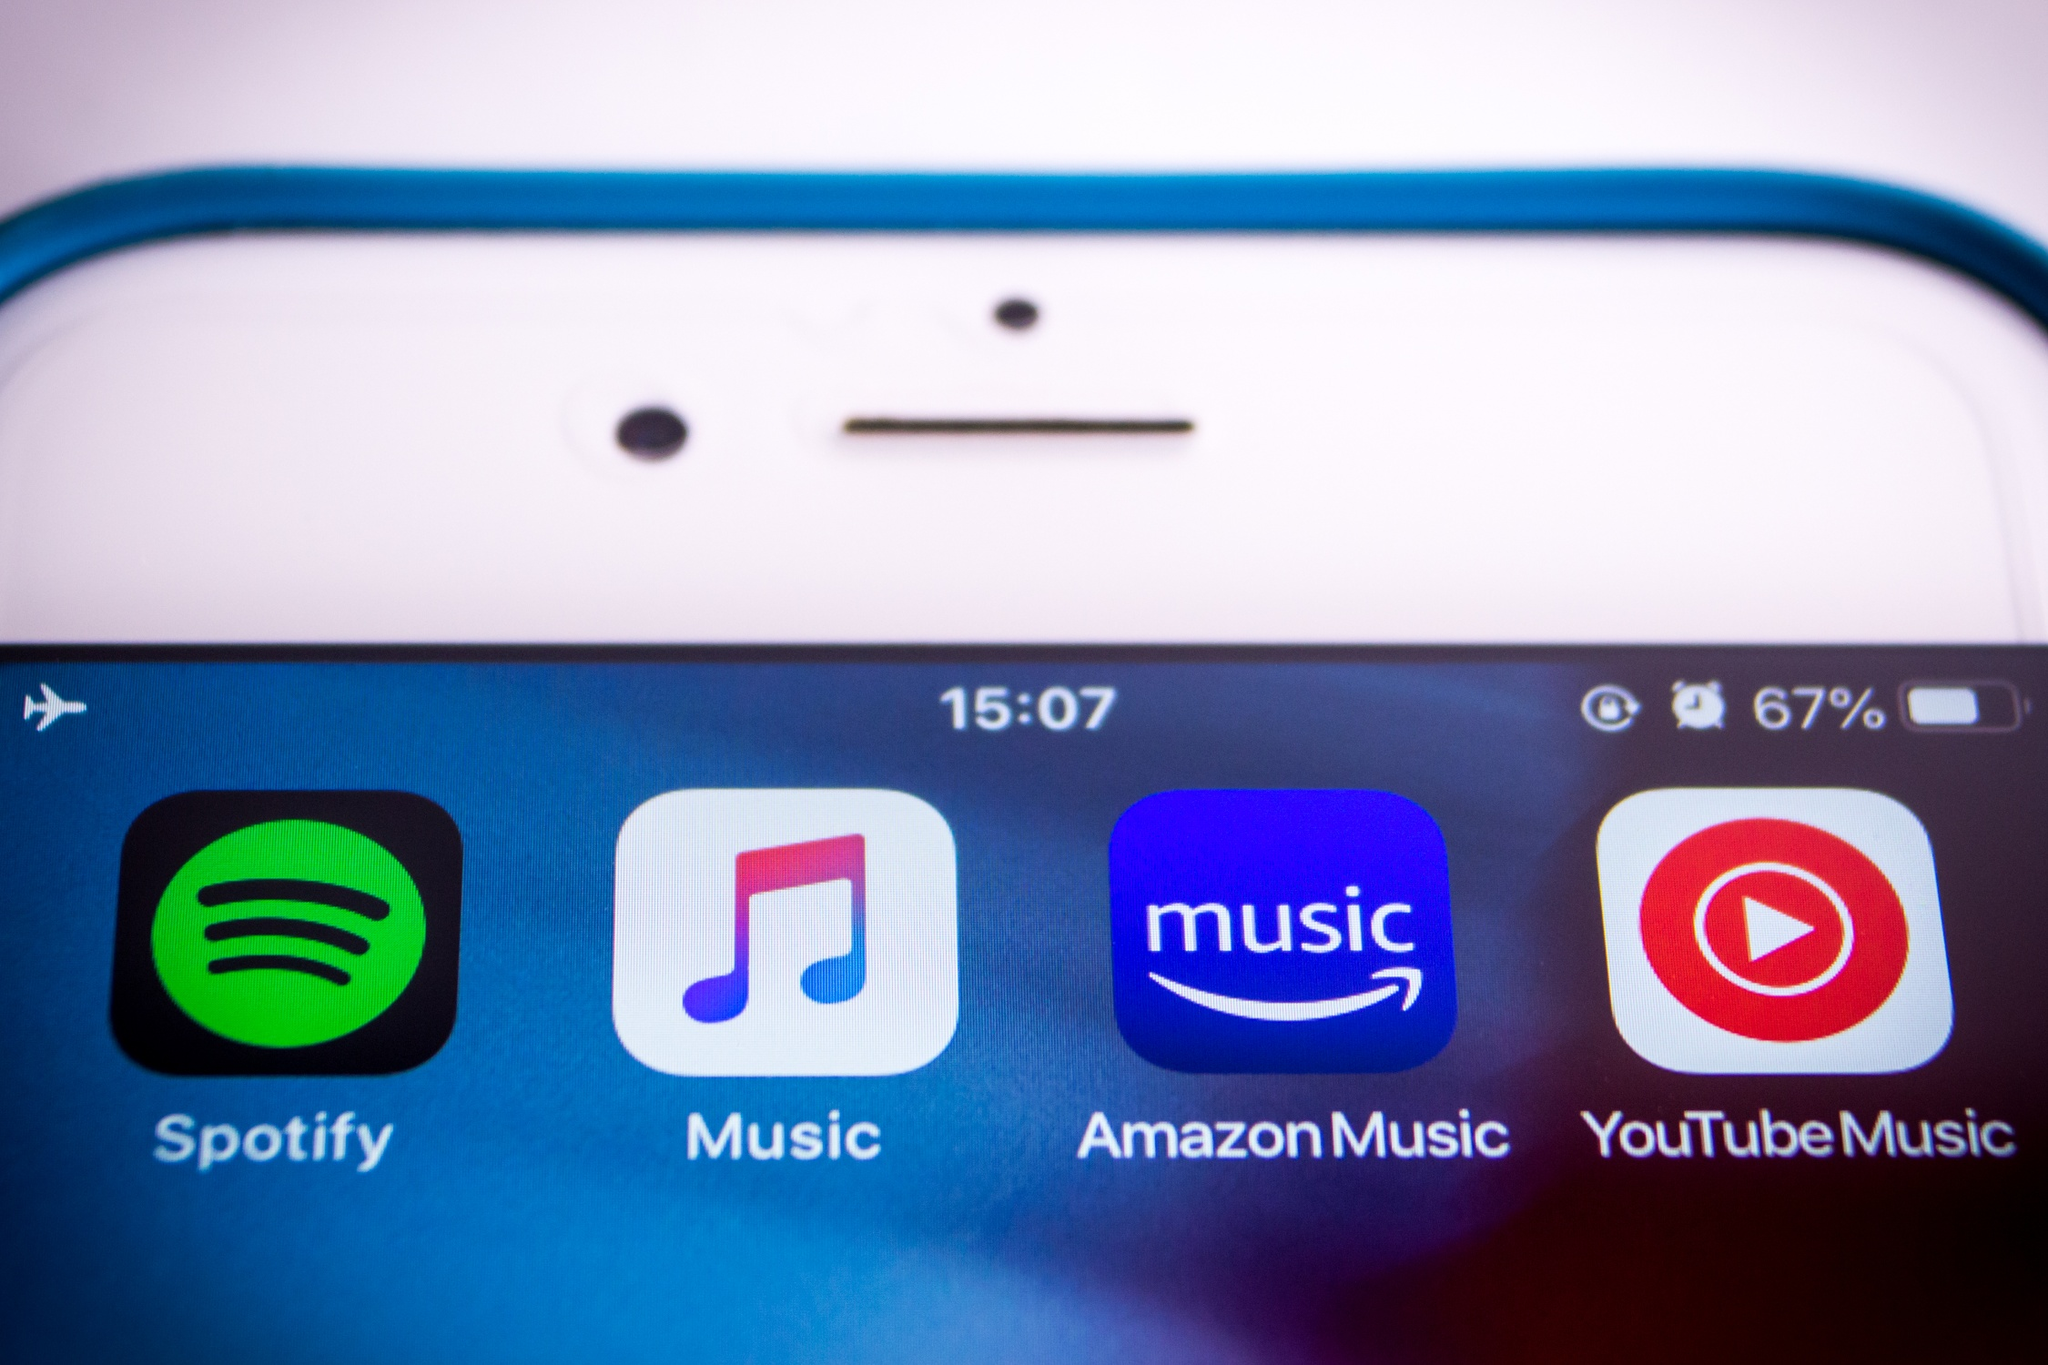Can you describe the significance of each music streaming service displayed on the phone? Certainly! Here's a brief overview of the music streaming services displayed:

- **Spotify:** Known for its vast library and personalized playlists, Spotify is a leading music streaming service that offers both free and premium subscriptions. Its green logo is instantly recognizable.

- **Apple Music:** As part of Apple's ecosystem, Apple Music allows users to stream and download songs. It integrates well with other Apple devices and offers curated playlists, radio shows, and more.

- **Amazon Music:** Amazon Music provides a variety of streaming options, including Amazon Music Unlimited and Prime Music for Amazon Prime members. It's known for its extensive catalog and compatibility with Alexa.

- **YouTube Music:** YouTube Music is a service that combines music videos and audio streaming. It leverages YouTube's vast video library to offer unique features like music video integration and personalized recommendations. 